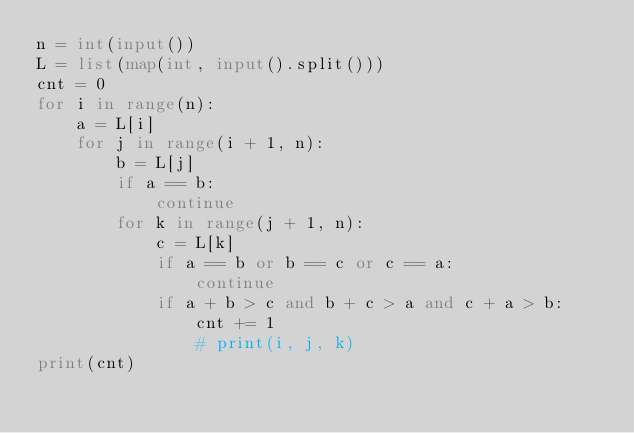<code> <loc_0><loc_0><loc_500><loc_500><_Python_>n = int(input())
L = list(map(int, input().split()))
cnt = 0
for i in range(n):
    a = L[i]
    for j in range(i + 1, n):
        b = L[j]
        if a == b:
            continue
        for k in range(j + 1, n):
            c = L[k]
            if a == b or b == c or c == a:
                continue
            if a + b > c and b + c > a and c + a > b:
                cnt += 1
                # print(i, j, k)
print(cnt)
</code> 